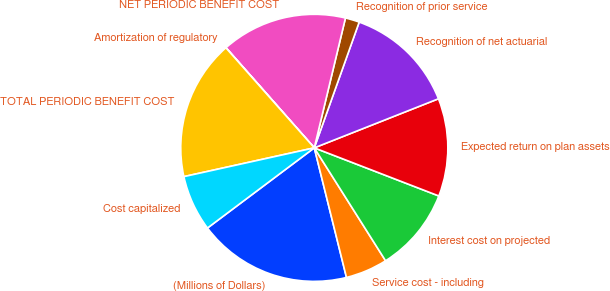Convert chart. <chart><loc_0><loc_0><loc_500><loc_500><pie_chart><fcel>(Millions of Dollars)<fcel>Service cost - including<fcel>Interest cost on projected<fcel>Expected return on plan assets<fcel>Recognition of net actuarial<fcel>Recognition of prior service<fcel>NET PERIODIC BENEFIT COST<fcel>Amortization of regulatory<fcel>TOTAL PERIODIC BENEFIT COST<fcel>Cost capitalized<nl><fcel>18.63%<fcel>5.09%<fcel>10.17%<fcel>11.86%<fcel>13.55%<fcel>1.71%<fcel>15.25%<fcel>0.02%<fcel>16.94%<fcel>6.79%<nl></chart> 